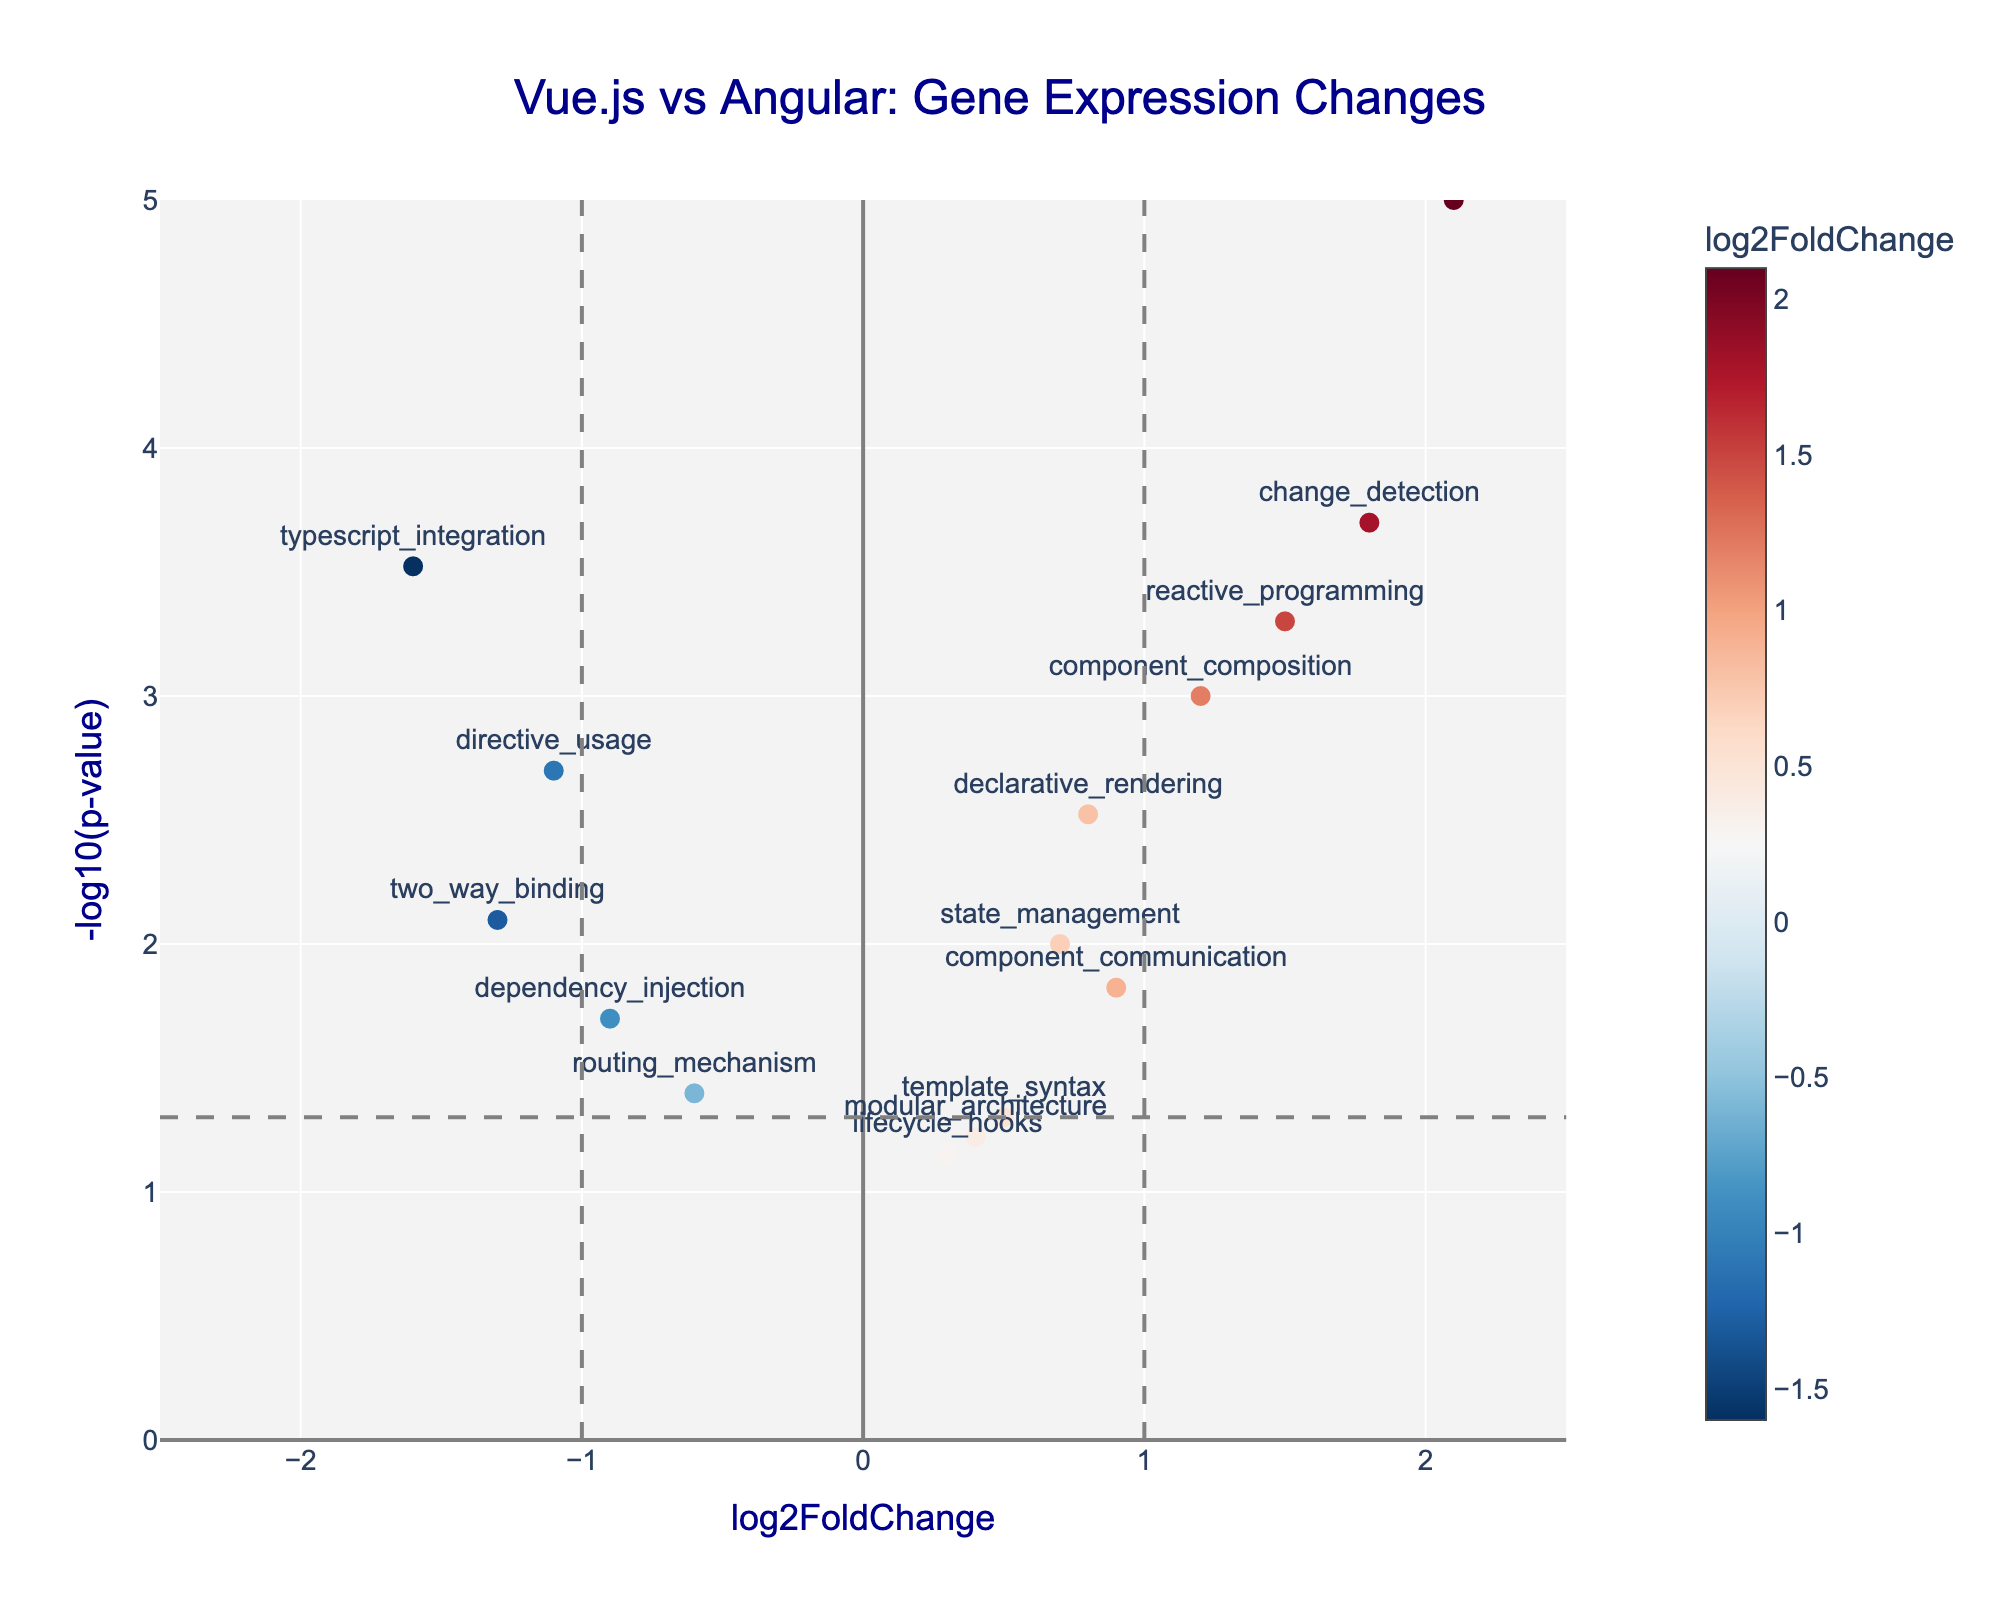What is the title of the plot? The title of the plot is displayed prominently at the top center of the figure. By reading the title, "Vue.js vs Angular: Gene Expression Changes," we can identify the overarching topic of the plot.
Answer: Vue.js vs Angular: Gene Expression Changes How many genes have a log2FoldChange greater than 1? To determine this, we count the number of data points (genes) that have a log2FoldChange value greater than 1 on the horizontal axis.
Answer: 4 Which gene has the highest -log10(p-value)? We need to look at the vertical axis and identify the data point that is positioned the highest. The gene text associated with this highest point corresponds to the highest -log10(p-value).
Answer: virtual_dom Which genes are considered upregulated in Vue.js developers' brains? Upregulated genes have a positive log2FoldChange value and meet the statistical significance threshold (usually a -log10(p-value) greater than 1.3). By looking at the points with a log2FoldChange > 0 and -log10(p-value) > 1.3, we identify the relevant genes.
Answer: component_composition, declarative_rendering, reactive_programming, change_detection, virtual_dom What is the log2FoldChange and p-value of the 'directive_usage' gene? The position of 'directive_usage' on the plot gives its log2FoldChange value and -log10(p-value). We can read these values directly, or from the hover text.
Answer: log2FoldChange: -1.1, p-value: 0.002 Which gene shows a stronger downregulation (more negative log2FoldChange) compared to 'dependency_injection'? By comparing the log2FoldChange values of other genes that are less than the value for 'dependency_injection' (-0.9), we can find the strongest negative one.
Answer: typescript_integration How many genes have a p-value lower than 0.01? We convert the threshold 0.01 to -log10(p-value), which roughly equals 2. By counting the data points above this value on the vertical axis, we determine the number of genes meeting this criterion.
Answer: 5 Which gene has the largest positive log2FoldChange? The gene with the largest positive log2FoldChange is identified by looking at the farthest point to the right on the horizontal axis.
Answer: virtual_dom What threshold separates statistically significant p-values on the plot? The threshold for statistical significance is typically set at -log10(p-value) = 1.3, represented by a horizontal dashed grey line on the plot.
Answer: 0.05 